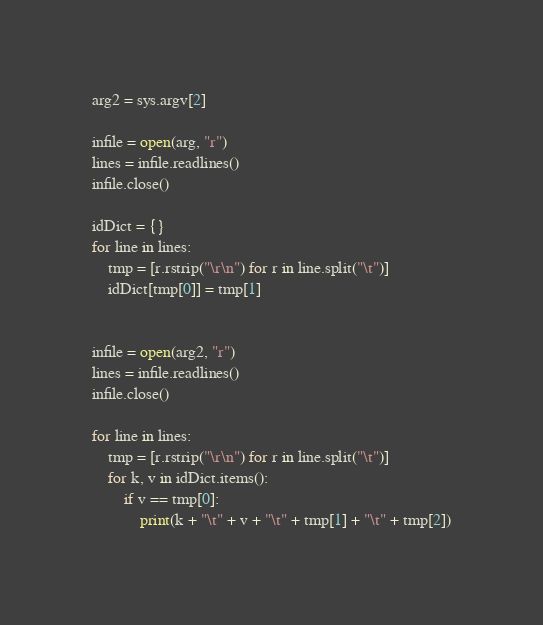<code> <loc_0><loc_0><loc_500><loc_500><_Python_>arg2 = sys.argv[2]

infile = open(arg, "r")
lines = infile.readlines()
infile.close()

idDict = {}
for line in lines:
    tmp = [r.rstrip("\r\n") for r in line.split("\t")]
    idDict[tmp[0]] = tmp[1]


infile = open(arg2, "r")
lines = infile.readlines()
infile.close()

for line in lines:
    tmp = [r.rstrip("\r\n") for r in line.split("\t")]
    for k, v in idDict.items():
        if v == tmp[0]:
            print(k + "\t" + v + "\t" + tmp[1] + "\t" + tmp[2])
</code> 